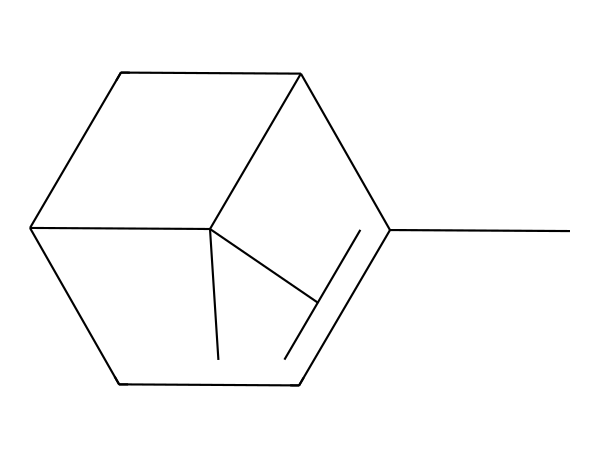How many carbon atoms are present in this molecule? By examining the SMILES representation, it can be determined that there are a total of 10 carbon atoms (C) present in the structure of pinene.
Answer: 10 What is the degree of saturation for this compound? The degree of saturation can be calculated using the formula: DBE = C - H/2 + N/2 + 1. For this compound, we have 10 carbon atoms and 16 hydrogen atoms (derived from the structure), leading to a degree of saturation of 5.
Answer: 5 Is this molecule a cyclic compound? The presence of rings in the structure can be identified in the SMILES representation, as indicated by the numbers (1 and 2). Therefore, this molecule does indeed form a cyclic structure.
Answer: Yes What functional group is predominantly found in pinene? Analyzing the structure and considering its classification, pinene is characterized as a monoterpene, which contains a C=C double bond and does not specifically exhibit any other functional group such as alcohol or carbonyl.
Answer: Monoterpene Does this compound contain any double bonds? By examining the SMILES representation closely, it reveals the existence of double bonds between certain carbon atoms, indicating that this molecule does indeed contain C=C double bonds.
Answer: Yes What properties of pinene make it suitable for eco-friendly cleaning products? Pinene's properties include being a natural solvent, having antimicrobial activity, and its pleasant scent, making it appealing for use in products aimed at environmental sustainability.
Answer: Natural solvent 